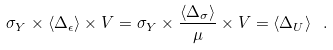<formula> <loc_0><loc_0><loc_500><loc_500>\sigma _ { Y } \times \langle \Delta _ { \epsilon } \rangle \times V = \sigma _ { Y } \times \frac { \langle \Delta _ { \sigma } \rangle } { \mu } \times V = \langle \Delta _ { U } \rangle \ .</formula> 